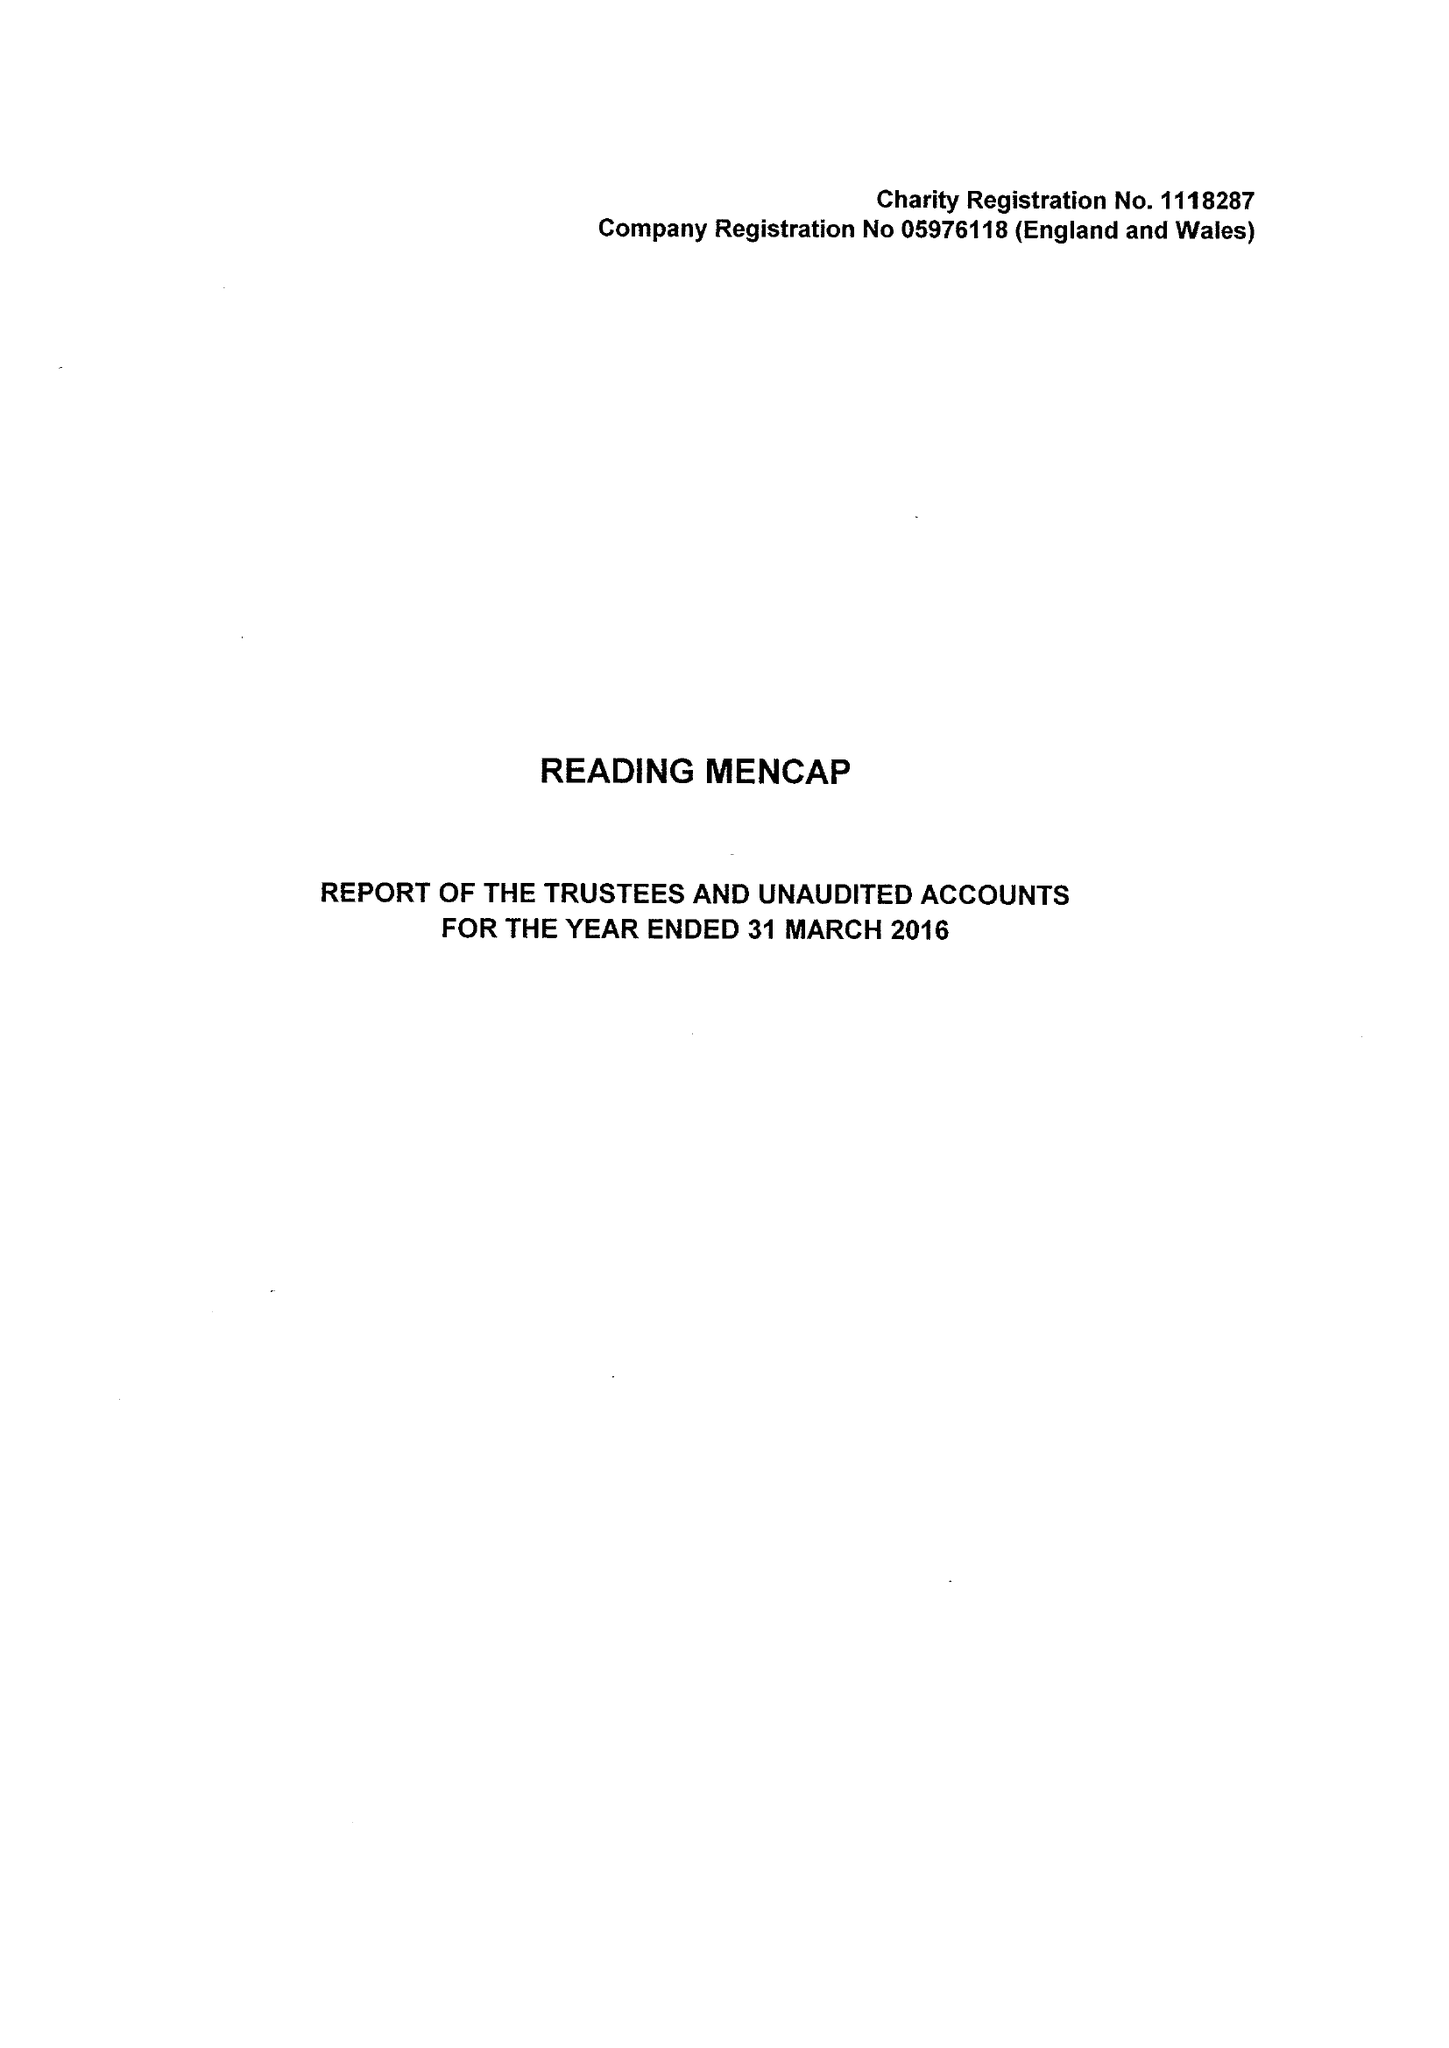What is the value for the spending_annually_in_british_pounds?
Answer the question using a single word or phrase. 344022.00 